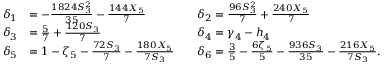<formula> <loc_0><loc_0><loc_500><loc_500>\begin{array} { r l r l } { \delta _ { 1 } } & { = - \frac { 1 8 2 4 S _ { 3 } ^ { 2 } } { 3 5 } - \frac { 1 4 4 X _ { 5 } } { 7 } } & & { \delta _ { 2 } = \frac { 9 6 S _ { 3 } ^ { 2 } } { 7 } + \frac { 2 4 0 X _ { 5 } } { 7 } } \\ { \delta _ { 3 } } & { = \frac { 5 } { 7 } + \frac { 1 2 0 S _ { 3 } } { 7 } } & & { \delta _ { 4 } = \gamma _ { 4 } - h _ { 4 } } \\ { \delta _ { 5 } } & { = 1 - \zeta _ { 5 } - \frac { 7 2 S _ { 3 } } { 7 } - \frac { 1 8 0 X _ { 5 } } { 7 S _ { 3 } } } & & { \delta _ { 6 } = \frac { 3 } { 5 } - \frac { 6 \zeta _ { 5 } } { 5 } - \frac { 9 3 6 S _ { 3 } } { 3 5 } - \frac { 2 1 6 X _ { 5 } } { 7 S _ { 3 } } . } \end{array}</formula> 